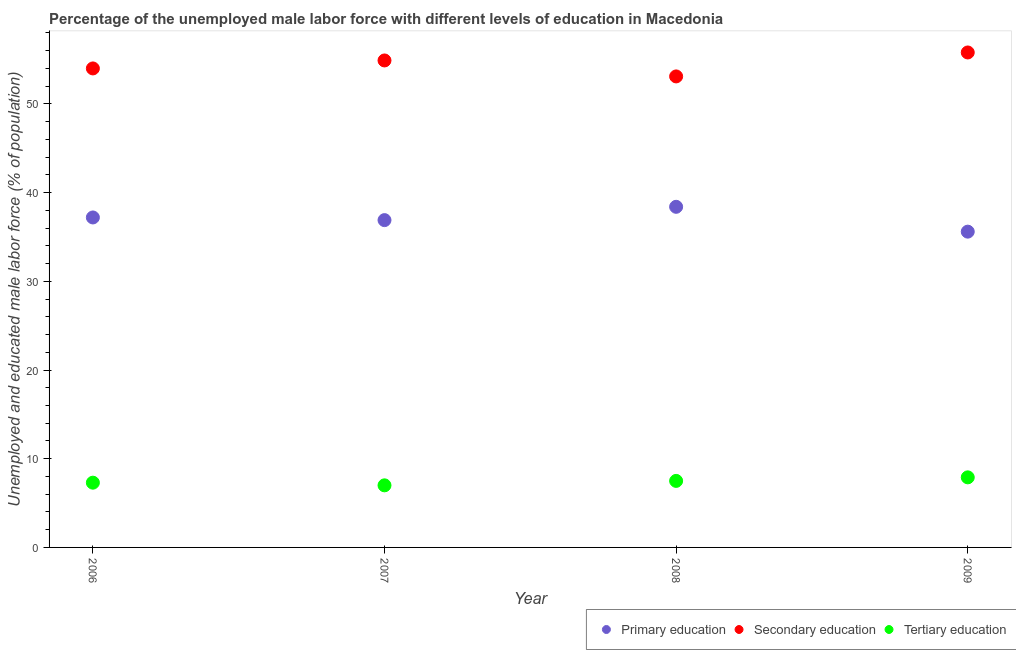Across all years, what is the maximum percentage of male labor force who received secondary education?
Offer a terse response. 55.8. Across all years, what is the minimum percentage of male labor force who received primary education?
Provide a short and direct response. 35.6. In which year was the percentage of male labor force who received secondary education minimum?
Offer a terse response. 2008. What is the total percentage of male labor force who received tertiary education in the graph?
Give a very brief answer. 29.7. What is the difference between the percentage of male labor force who received primary education in 2009 and the percentage of male labor force who received secondary education in 2008?
Provide a succinct answer. -17.5. What is the average percentage of male labor force who received tertiary education per year?
Offer a very short reply. 7.43. In the year 2009, what is the difference between the percentage of male labor force who received secondary education and percentage of male labor force who received tertiary education?
Provide a short and direct response. 47.9. What is the ratio of the percentage of male labor force who received primary education in 2008 to that in 2009?
Your response must be concise. 1.08. Is the difference between the percentage of male labor force who received tertiary education in 2007 and 2008 greater than the difference between the percentage of male labor force who received primary education in 2007 and 2008?
Provide a succinct answer. Yes. What is the difference between the highest and the second highest percentage of male labor force who received tertiary education?
Your response must be concise. 0.4. What is the difference between the highest and the lowest percentage of male labor force who received tertiary education?
Ensure brevity in your answer.  0.9. In how many years, is the percentage of male labor force who received tertiary education greater than the average percentage of male labor force who received tertiary education taken over all years?
Make the answer very short. 2. Is it the case that in every year, the sum of the percentage of male labor force who received primary education and percentage of male labor force who received secondary education is greater than the percentage of male labor force who received tertiary education?
Ensure brevity in your answer.  Yes. Does the percentage of male labor force who received primary education monotonically increase over the years?
Offer a terse response. No. Is the percentage of male labor force who received primary education strictly greater than the percentage of male labor force who received secondary education over the years?
Offer a terse response. No. Is the percentage of male labor force who received secondary education strictly less than the percentage of male labor force who received primary education over the years?
Provide a short and direct response. No. Are the values on the major ticks of Y-axis written in scientific E-notation?
Give a very brief answer. No. Does the graph contain grids?
Your answer should be very brief. No. Where does the legend appear in the graph?
Your answer should be compact. Bottom right. How many legend labels are there?
Provide a short and direct response. 3. How are the legend labels stacked?
Keep it short and to the point. Horizontal. What is the title of the graph?
Provide a short and direct response. Percentage of the unemployed male labor force with different levels of education in Macedonia. What is the label or title of the Y-axis?
Your response must be concise. Unemployed and educated male labor force (% of population). What is the Unemployed and educated male labor force (% of population) of Primary education in 2006?
Provide a succinct answer. 37.2. What is the Unemployed and educated male labor force (% of population) in Tertiary education in 2006?
Ensure brevity in your answer.  7.3. What is the Unemployed and educated male labor force (% of population) of Primary education in 2007?
Ensure brevity in your answer.  36.9. What is the Unemployed and educated male labor force (% of population) of Secondary education in 2007?
Give a very brief answer. 54.9. What is the Unemployed and educated male labor force (% of population) of Primary education in 2008?
Offer a terse response. 38.4. What is the Unemployed and educated male labor force (% of population) of Secondary education in 2008?
Offer a very short reply. 53.1. What is the Unemployed and educated male labor force (% of population) of Primary education in 2009?
Make the answer very short. 35.6. What is the Unemployed and educated male labor force (% of population) of Secondary education in 2009?
Your answer should be compact. 55.8. What is the Unemployed and educated male labor force (% of population) in Tertiary education in 2009?
Provide a short and direct response. 7.9. Across all years, what is the maximum Unemployed and educated male labor force (% of population) of Primary education?
Keep it short and to the point. 38.4. Across all years, what is the maximum Unemployed and educated male labor force (% of population) of Secondary education?
Offer a terse response. 55.8. Across all years, what is the maximum Unemployed and educated male labor force (% of population) in Tertiary education?
Offer a terse response. 7.9. Across all years, what is the minimum Unemployed and educated male labor force (% of population) of Primary education?
Make the answer very short. 35.6. Across all years, what is the minimum Unemployed and educated male labor force (% of population) in Secondary education?
Your answer should be compact. 53.1. What is the total Unemployed and educated male labor force (% of population) in Primary education in the graph?
Offer a terse response. 148.1. What is the total Unemployed and educated male labor force (% of population) of Secondary education in the graph?
Your response must be concise. 217.8. What is the total Unemployed and educated male labor force (% of population) in Tertiary education in the graph?
Give a very brief answer. 29.7. What is the difference between the Unemployed and educated male labor force (% of population) of Secondary education in 2006 and that in 2007?
Provide a short and direct response. -0.9. What is the difference between the Unemployed and educated male labor force (% of population) in Secondary education in 2006 and that in 2008?
Ensure brevity in your answer.  0.9. What is the difference between the Unemployed and educated male labor force (% of population) in Primary education in 2006 and that in 2009?
Provide a short and direct response. 1.6. What is the difference between the Unemployed and educated male labor force (% of population) of Tertiary education in 2006 and that in 2009?
Your answer should be compact. -0.6. What is the difference between the Unemployed and educated male labor force (% of population) in Primary education in 2007 and that in 2009?
Your answer should be compact. 1.3. What is the difference between the Unemployed and educated male labor force (% of population) of Tertiary education in 2008 and that in 2009?
Offer a very short reply. -0.4. What is the difference between the Unemployed and educated male labor force (% of population) of Primary education in 2006 and the Unemployed and educated male labor force (% of population) of Secondary education in 2007?
Give a very brief answer. -17.7. What is the difference between the Unemployed and educated male labor force (% of population) in Primary education in 2006 and the Unemployed and educated male labor force (% of population) in Tertiary education in 2007?
Ensure brevity in your answer.  30.2. What is the difference between the Unemployed and educated male labor force (% of population) in Secondary education in 2006 and the Unemployed and educated male labor force (% of population) in Tertiary education in 2007?
Provide a short and direct response. 47. What is the difference between the Unemployed and educated male labor force (% of population) of Primary education in 2006 and the Unemployed and educated male labor force (% of population) of Secondary education in 2008?
Your response must be concise. -15.9. What is the difference between the Unemployed and educated male labor force (% of population) of Primary education in 2006 and the Unemployed and educated male labor force (% of population) of Tertiary education in 2008?
Keep it short and to the point. 29.7. What is the difference between the Unemployed and educated male labor force (% of population) in Secondary education in 2006 and the Unemployed and educated male labor force (% of population) in Tertiary education in 2008?
Your answer should be very brief. 46.5. What is the difference between the Unemployed and educated male labor force (% of population) of Primary education in 2006 and the Unemployed and educated male labor force (% of population) of Secondary education in 2009?
Provide a short and direct response. -18.6. What is the difference between the Unemployed and educated male labor force (% of population) in Primary education in 2006 and the Unemployed and educated male labor force (% of population) in Tertiary education in 2009?
Make the answer very short. 29.3. What is the difference between the Unemployed and educated male labor force (% of population) in Secondary education in 2006 and the Unemployed and educated male labor force (% of population) in Tertiary education in 2009?
Your answer should be very brief. 46.1. What is the difference between the Unemployed and educated male labor force (% of population) of Primary education in 2007 and the Unemployed and educated male labor force (% of population) of Secondary education in 2008?
Offer a very short reply. -16.2. What is the difference between the Unemployed and educated male labor force (% of population) in Primary education in 2007 and the Unemployed and educated male labor force (% of population) in Tertiary education in 2008?
Your response must be concise. 29.4. What is the difference between the Unemployed and educated male labor force (% of population) in Secondary education in 2007 and the Unemployed and educated male labor force (% of population) in Tertiary education in 2008?
Keep it short and to the point. 47.4. What is the difference between the Unemployed and educated male labor force (% of population) of Primary education in 2007 and the Unemployed and educated male labor force (% of population) of Secondary education in 2009?
Your answer should be very brief. -18.9. What is the difference between the Unemployed and educated male labor force (% of population) in Secondary education in 2007 and the Unemployed and educated male labor force (% of population) in Tertiary education in 2009?
Your answer should be compact. 47. What is the difference between the Unemployed and educated male labor force (% of population) of Primary education in 2008 and the Unemployed and educated male labor force (% of population) of Secondary education in 2009?
Ensure brevity in your answer.  -17.4. What is the difference between the Unemployed and educated male labor force (% of population) of Primary education in 2008 and the Unemployed and educated male labor force (% of population) of Tertiary education in 2009?
Keep it short and to the point. 30.5. What is the difference between the Unemployed and educated male labor force (% of population) of Secondary education in 2008 and the Unemployed and educated male labor force (% of population) of Tertiary education in 2009?
Offer a terse response. 45.2. What is the average Unemployed and educated male labor force (% of population) in Primary education per year?
Give a very brief answer. 37.02. What is the average Unemployed and educated male labor force (% of population) in Secondary education per year?
Provide a succinct answer. 54.45. What is the average Unemployed and educated male labor force (% of population) in Tertiary education per year?
Give a very brief answer. 7.42. In the year 2006, what is the difference between the Unemployed and educated male labor force (% of population) of Primary education and Unemployed and educated male labor force (% of population) of Secondary education?
Provide a succinct answer. -16.8. In the year 2006, what is the difference between the Unemployed and educated male labor force (% of population) of Primary education and Unemployed and educated male labor force (% of population) of Tertiary education?
Your answer should be compact. 29.9. In the year 2006, what is the difference between the Unemployed and educated male labor force (% of population) of Secondary education and Unemployed and educated male labor force (% of population) of Tertiary education?
Your response must be concise. 46.7. In the year 2007, what is the difference between the Unemployed and educated male labor force (% of population) of Primary education and Unemployed and educated male labor force (% of population) of Tertiary education?
Ensure brevity in your answer.  29.9. In the year 2007, what is the difference between the Unemployed and educated male labor force (% of population) of Secondary education and Unemployed and educated male labor force (% of population) of Tertiary education?
Offer a terse response. 47.9. In the year 2008, what is the difference between the Unemployed and educated male labor force (% of population) in Primary education and Unemployed and educated male labor force (% of population) in Secondary education?
Give a very brief answer. -14.7. In the year 2008, what is the difference between the Unemployed and educated male labor force (% of population) of Primary education and Unemployed and educated male labor force (% of population) of Tertiary education?
Provide a short and direct response. 30.9. In the year 2008, what is the difference between the Unemployed and educated male labor force (% of population) of Secondary education and Unemployed and educated male labor force (% of population) of Tertiary education?
Your response must be concise. 45.6. In the year 2009, what is the difference between the Unemployed and educated male labor force (% of population) in Primary education and Unemployed and educated male labor force (% of population) in Secondary education?
Your answer should be compact. -20.2. In the year 2009, what is the difference between the Unemployed and educated male labor force (% of population) in Primary education and Unemployed and educated male labor force (% of population) in Tertiary education?
Your answer should be compact. 27.7. In the year 2009, what is the difference between the Unemployed and educated male labor force (% of population) in Secondary education and Unemployed and educated male labor force (% of population) in Tertiary education?
Provide a succinct answer. 47.9. What is the ratio of the Unemployed and educated male labor force (% of population) of Secondary education in 2006 to that in 2007?
Provide a succinct answer. 0.98. What is the ratio of the Unemployed and educated male labor force (% of population) in Tertiary education in 2006 to that in 2007?
Keep it short and to the point. 1.04. What is the ratio of the Unemployed and educated male labor force (% of population) of Primary education in 2006 to that in 2008?
Keep it short and to the point. 0.97. What is the ratio of the Unemployed and educated male labor force (% of population) of Secondary education in 2006 to that in 2008?
Give a very brief answer. 1.02. What is the ratio of the Unemployed and educated male labor force (% of population) in Tertiary education in 2006 to that in 2008?
Give a very brief answer. 0.97. What is the ratio of the Unemployed and educated male labor force (% of population) in Primary education in 2006 to that in 2009?
Your answer should be very brief. 1.04. What is the ratio of the Unemployed and educated male labor force (% of population) in Secondary education in 2006 to that in 2009?
Your answer should be very brief. 0.97. What is the ratio of the Unemployed and educated male labor force (% of population) of Tertiary education in 2006 to that in 2009?
Make the answer very short. 0.92. What is the ratio of the Unemployed and educated male labor force (% of population) of Primary education in 2007 to that in 2008?
Offer a very short reply. 0.96. What is the ratio of the Unemployed and educated male labor force (% of population) in Secondary education in 2007 to that in 2008?
Your answer should be compact. 1.03. What is the ratio of the Unemployed and educated male labor force (% of population) of Primary education in 2007 to that in 2009?
Your answer should be compact. 1.04. What is the ratio of the Unemployed and educated male labor force (% of population) of Secondary education in 2007 to that in 2009?
Offer a terse response. 0.98. What is the ratio of the Unemployed and educated male labor force (% of population) in Tertiary education in 2007 to that in 2009?
Make the answer very short. 0.89. What is the ratio of the Unemployed and educated male labor force (% of population) of Primary education in 2008 to that in 2009?
Your answer should be compact. 1.08. What is the ratio of the Unemployed and educated male labor force (% of population) in Secondary education in 2008 to that in 2009?
Make the answer very short. 0.95. What is the ratio of the Unemployed and educated male labor force (% of population) of Tertiary education in 2008 to that in 2009?
Give a very brief answer. 0.95. What is the difference between the highest and the second highest Unemployed and educated male labor force (% of population) of Primary education?
Offer a terse response. 1.2. What is the difference between the highest and the second highest Unemployed and educated male labor force (% of population) in Secondary education?
Ensure brevity in your answer.  0.9. What is the difference between the highest and the lowest Unemployed and educated male labor force (% of population) of Secondary education?
Your answer should be compact. 2.7. 